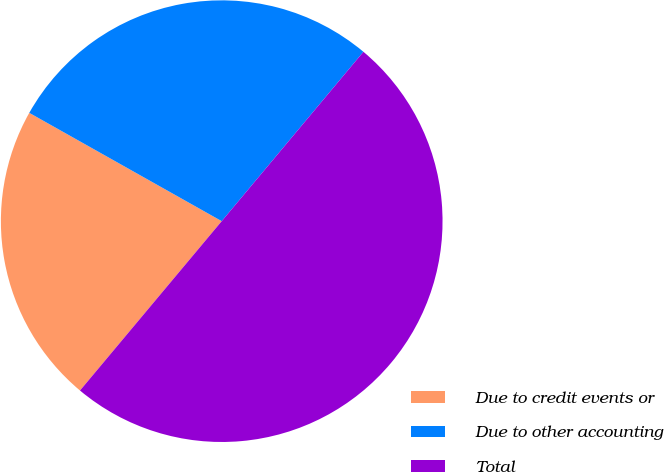Convert chart. <chart><loc_0><loc_0><loc_500><loc_500><pie_chart><fcel>Due to credit events or<fcel>Due to other accounting<fcel>Total<nl><fcel>22.07%<fcel>27.93%<fcel>50.0%<nl></chart> 